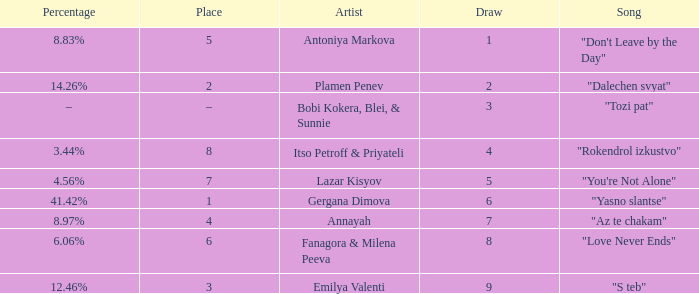Which Percentage has a Draw of 6? 41.42%. 